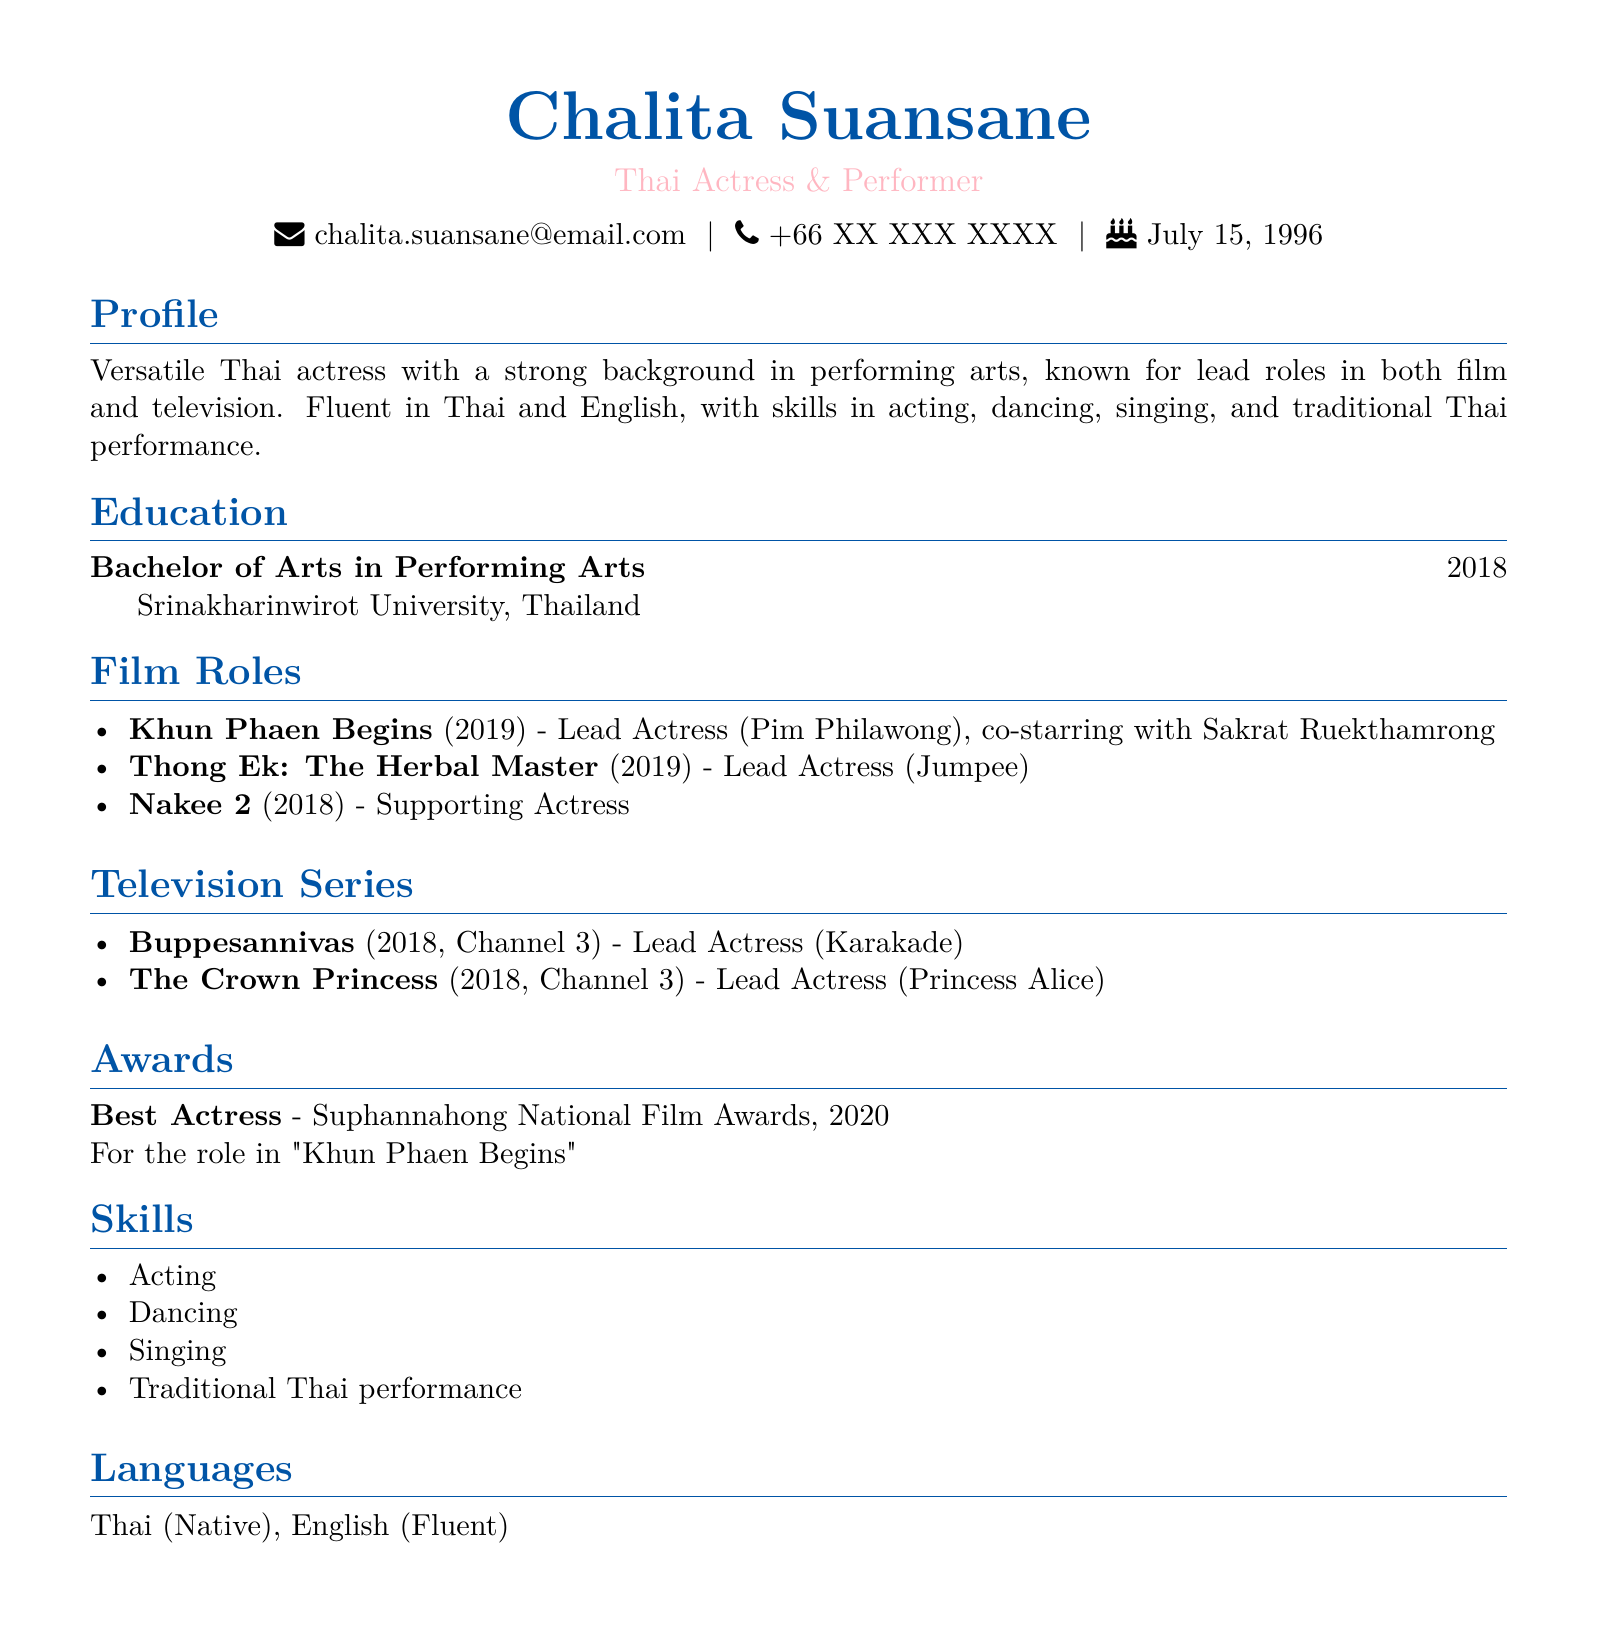What is the name of the actress? The document prominently features the name of the actress as Chalita Suansane.
Answer: Chalita Suansane What degree did she earn? The highest educational qualification mentioned is a Bachelor of Arts in Performing Arts.
Answer: Bachelor of Arts in Performing Arts In what year did she issue her graduation? The document states that she graduated in the year 2018.
Answer: 2018 Which project did she co-star in with Sakrat Ruekthamrong? The title of the film where she co-starred with Sakrat Ruekthamrong is "Khun Phaen Begins."
Answer: Khun Phaen Begins What was her role in "Buppesannivas"? The document specifies her role in the television series as Lead Actress (Karakade).
Answer: Lead Actress (Karakade) How many awards has she won? The document only mentions one specific award she has won for her acting.
Answer: 1 What skills does she have? The skills listed in her CV include acting, dancing, singing, and traditional Thai performance.
Answer: Acting, Dancing, Singing, Traditional Thai performance What channel aired "The Crown Princess"? The document notes that "The Crown Princess" was aired on Channel 3.
Answer: Channel 3 What is her date of birth? The document cites July 15, 1996, as her date of birth.
Answer: July 15, 1996 